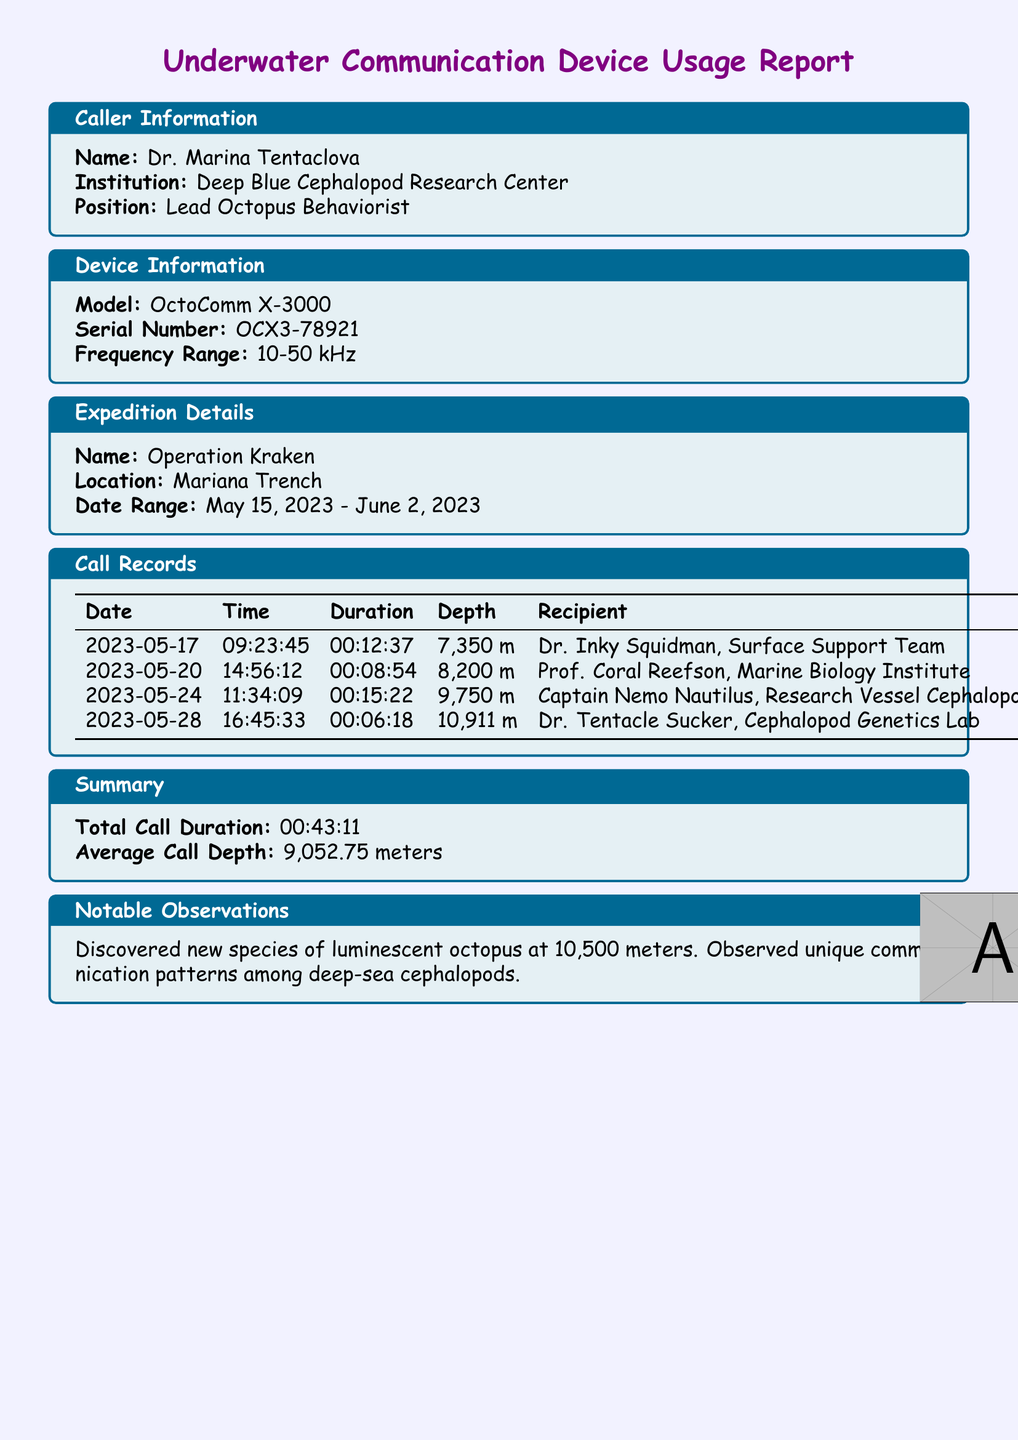What is the name of the lead researcher? The lead researcher is identified in the document as Dr. Marina Tentaclova under Caller Information.
Answer: Dr. Marina Tentaclova What is the model of the underwater communication device? The document specifies the model of the device in the Device Information section.
Answer: OctoComm X-3000 What was the average call depth during the expedition? The average call depth is calculated from the call records and is provided in the Summary section.
Answer: 9,052.75 meters How many calls were made during the expedition? The number of calls can be counted from the entries in the Call Records table.
Answer: 4 What is the total call duration? The total call duration is mentioned in the Summary section of the document.
Answer: 00:43:11 What notable observation was made during the expedition? The notable observation is detailed in the Notable Observations section of the document.
Answer: Discovered new species of luminescent octopus at 10,500 meters What date range did the expedition cover? The date range for the expedition is specified in the Expedition Details section of the document.
Answer: May 15, 2023 - June 2, 2023 Who did Dr. Marina Tentaclova communicate with on May 20, 2023? The recipient of the call can be found in the Call Records section, matching with the specified date.
Answer: Prof. Coral Reefson, Marine Biology Institute 